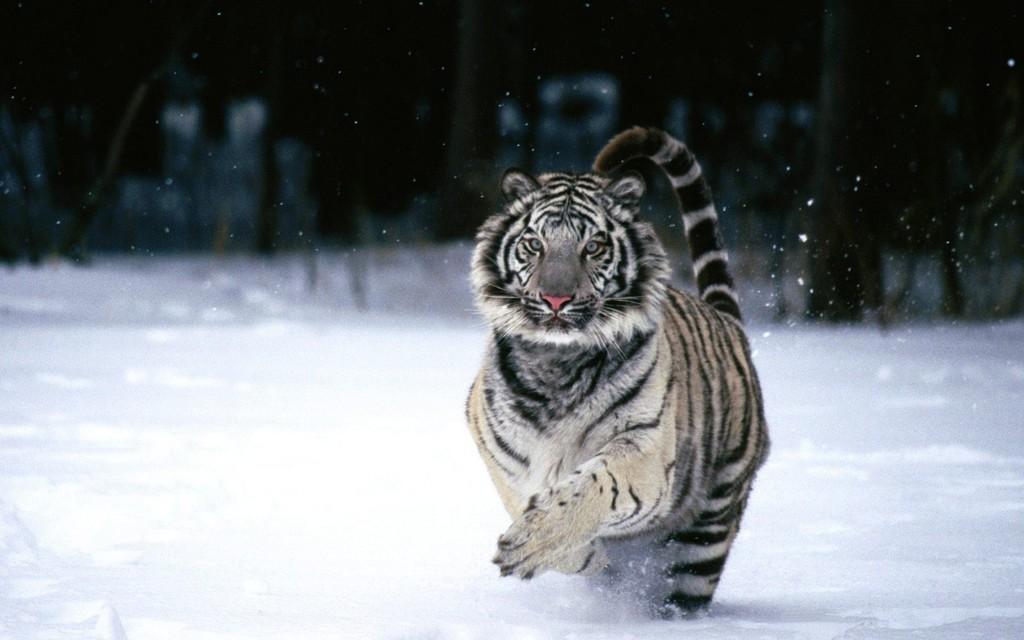Please provide a concise description of this image. In this image there is a tiger on a snowy surface, in the background it is dark. 